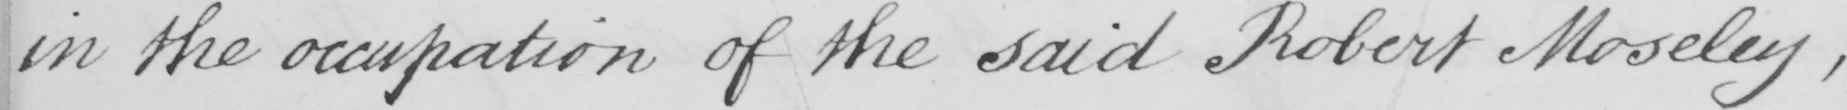Can you tell me what this handwritten text says? in the occupation of the said Robert Moseley , 